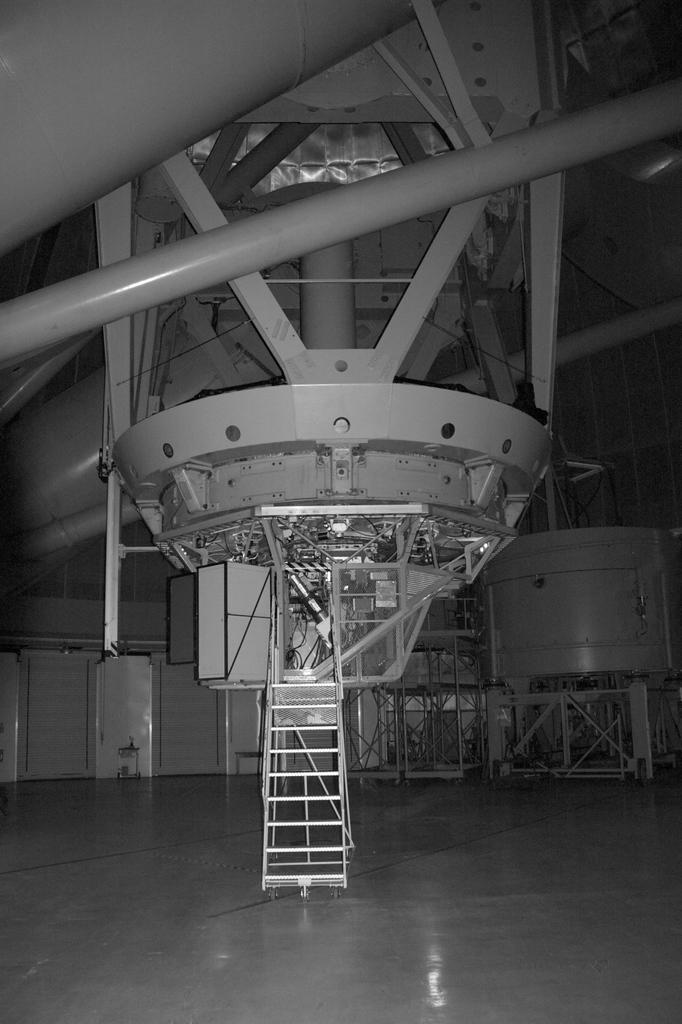What is placed on the floor in the image? There is a ladder on the floor in the image. Can you describe any objects visible in the image? There are objects in the image, but their specific details are not mentioned in the provided facts. What can be seen in the background of the image? There is a wall and rods in the background of the image. What type of desk can be seen in the image? There is no desk present in the image. Is the sun visible in the image? The provided facts do not mention the presence of the sun in the image. 